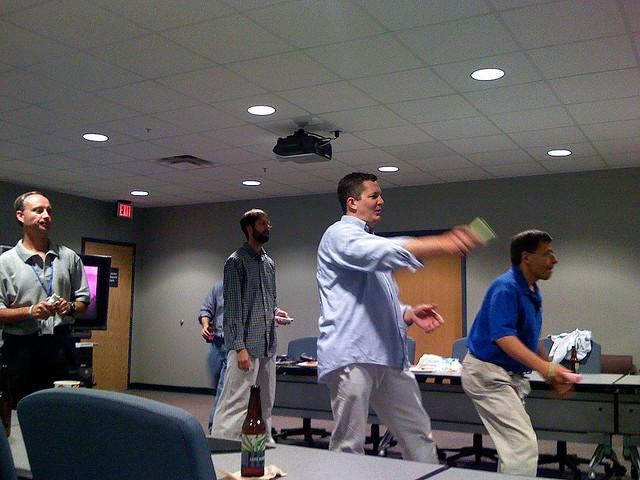What is everyone doing standing with remotes? playing games 